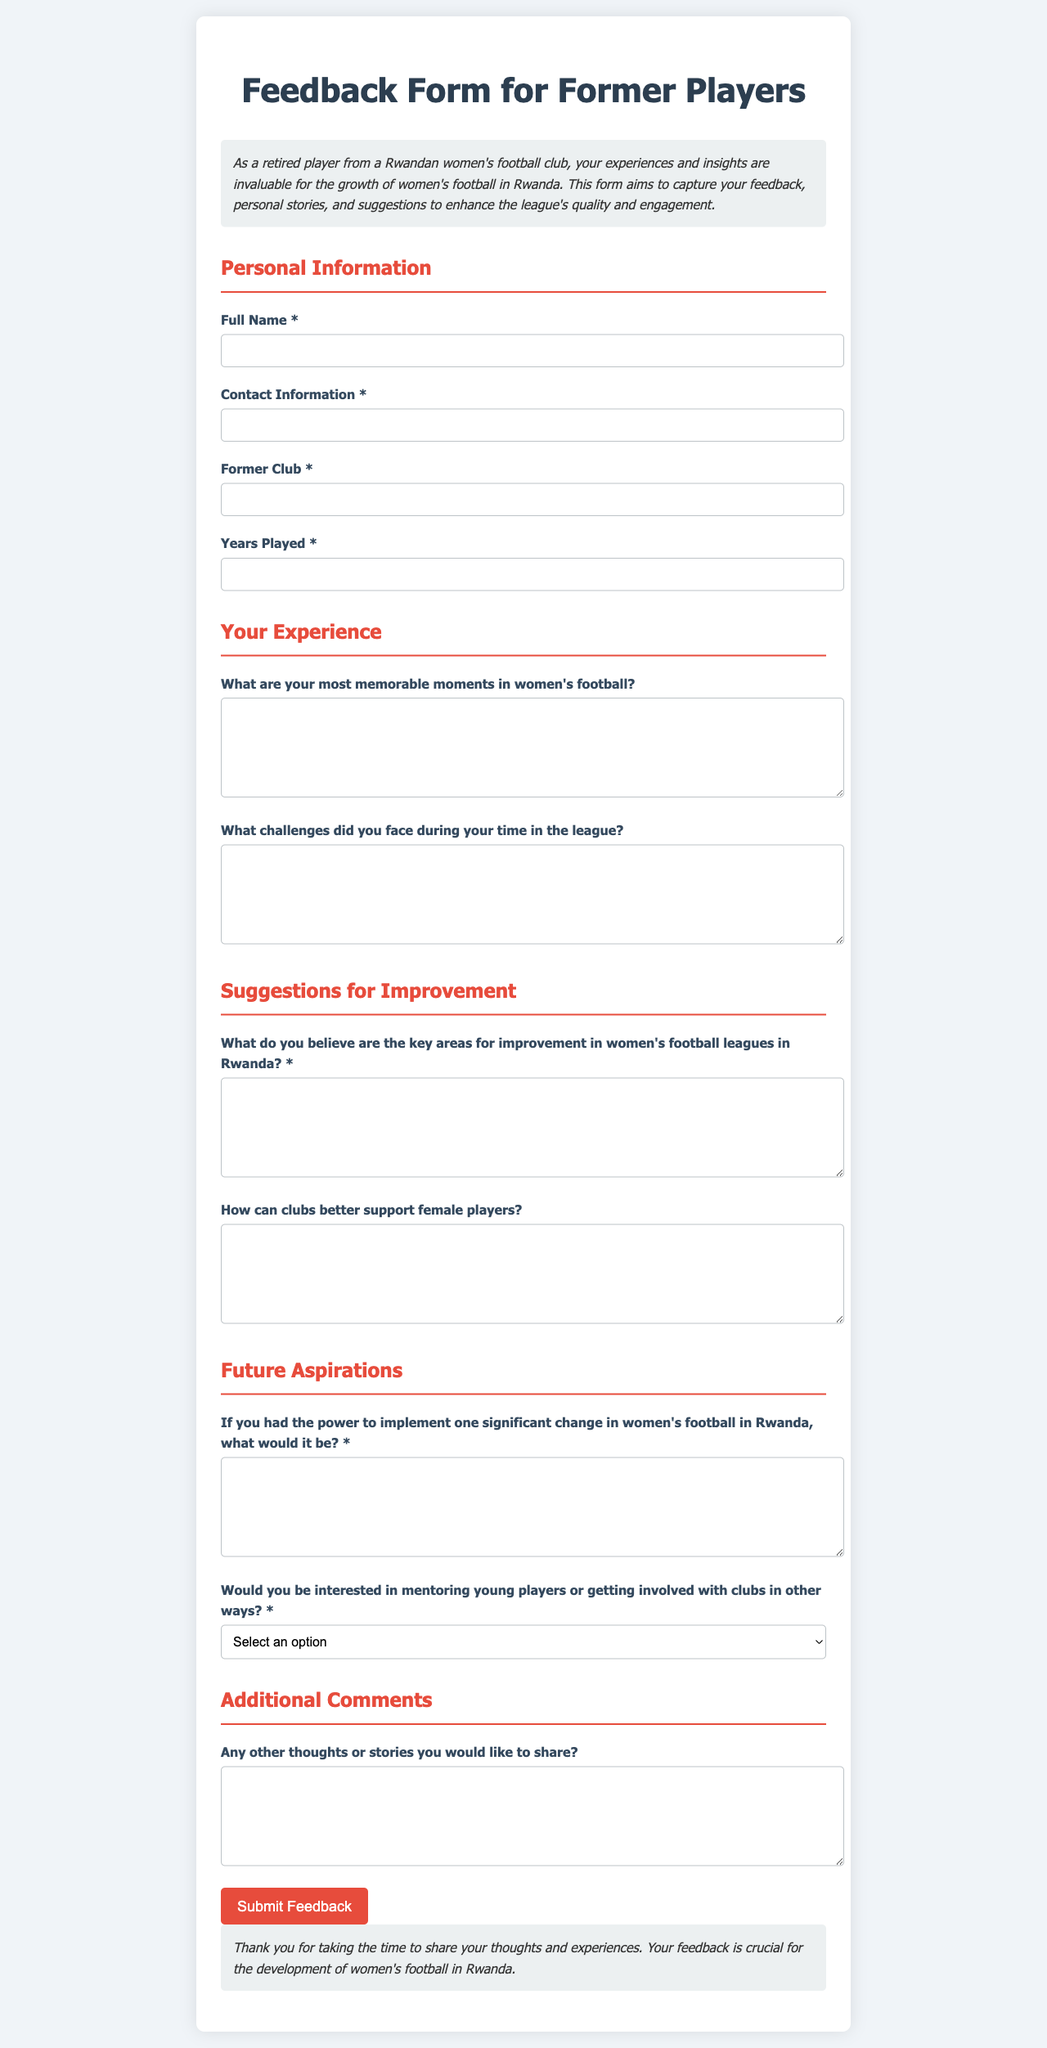What is the title of the document? The title appears prominently at the top of the document, indicating its purpose.
Answer: Feedback Form for Former Players What color is the background of the document? The background color of the document is specified in the CSS style.
Answer: #f0f4f8 How many main sections are in the form? The form contains several distinct sections, each addressing different topics.
Answer: Five What is the required input for "Former Club"? The form specifies information that users need to provide.
Answer: Text input What is the purpose of this feedback form? The introduction section provides insight into why the form is being used.
Answer: To capture feedback, personal stories, and suggestions Which area is required to indicate a player's interest in mentoring? The question specifically asks if players would like to get involved with mentoring.
Answer: Mentoring What is the color used for the headings? The color for the headings is defined in the document style.
Answer: #e74c3c How many years played is requested from participants? The document specifies a field for this information.
Answer: Text input What is the submit button's background color? The style for the submit button includes a specific color definition.
Answer: #e74c3c 